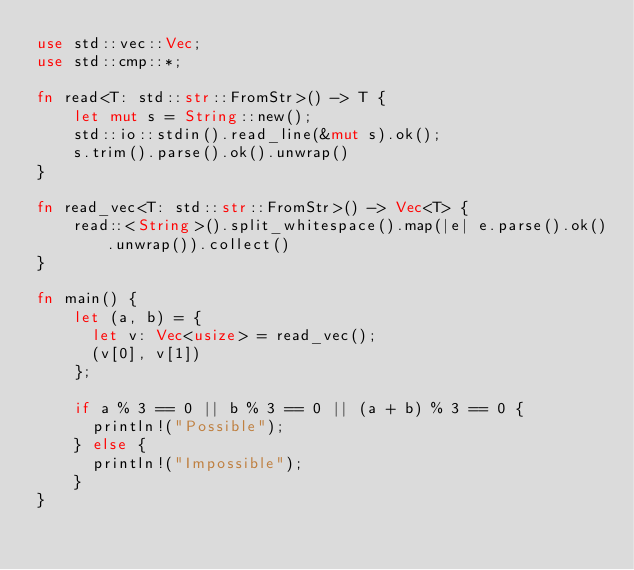<code> <loc_0><loc_0><loc_500><loc_500><_Rust_>use std::vec::Vec;
use std::cmp::*;

fn read<T: std::str::FromStr>() -> T {
    let mut s = String::new();
    std::io::stdin().read_line(&mut s).ok();
    s.trim().parse().ok().unwrap()
}

fn read_vec<T: std::str::FromStr>() -> Vec<T> {
    read::<String>().split_whitespace().map(|e| e.parse().ok().unwrap()).collect()
}

fn main() {
    let (a, b) = {
      let v: Vec<usize> = read_vec();
      (v[0], v[1])
    };

    if a % 3 == 0 || b % 3 == 0 || (a + b) % 3 == 0 {
      println!("Possible");
    } else {
      println!("Impossible");
    }
}
</code> 